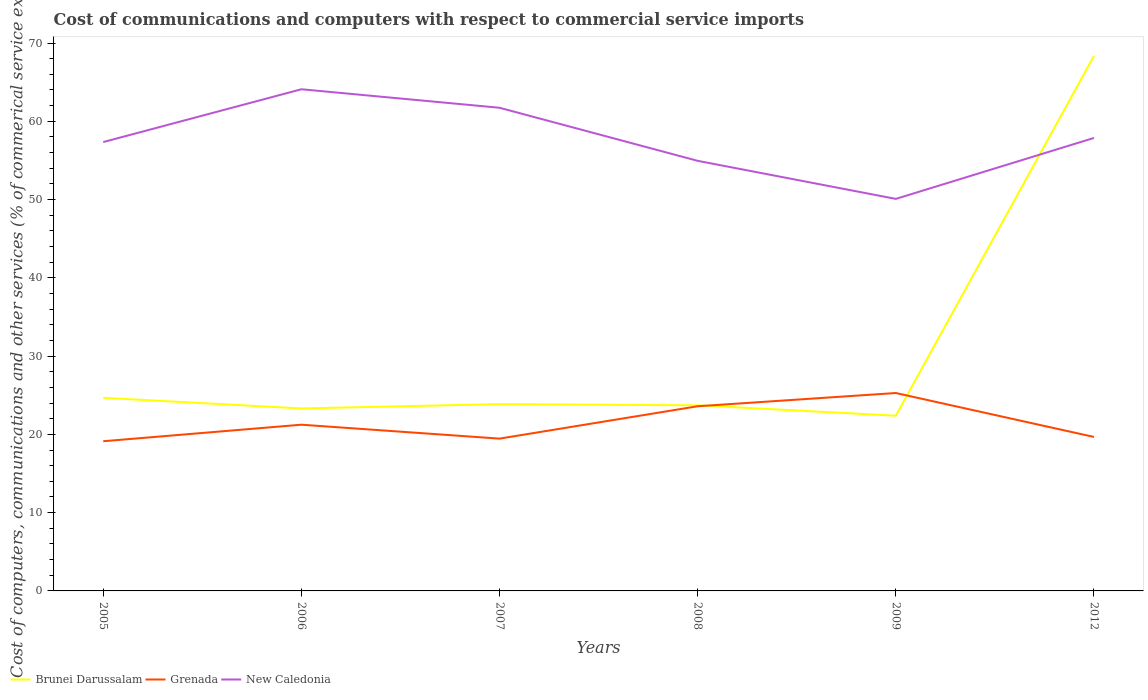Is the number of lines equal to the number of legend labels?
Offer a very short reply. Yes. Across all years, what is the maximum cost of communications and computers in Brunei Darussalam?
Your response must be concise. 22.39. In which year was the cost of communications and computers in New Caledonia maximum?
Provide a succinct answer. 2009. What is the total cost of communications and computers in Grenada in the graph?
Provide a short and direct response. -6.16. What is the difference between the highest and the second highest cost of communications and computers in Brunei Darussalam?
Keep it short and to the point. 45.97. What is the difference between the highest and the lowest cost of communications and computers in Brunei Darussalam?
Ensure brevity in your answer.  1. Is the cost of communications and computers in New Caledonia strictly greater than the cost of communications and computers in Grenada over the years?
Provide a succinct answer. No. How many lines are there?
Offer a very short reply. 3. How many years are there in the graph?
Make the answer very short. 6. How many legend labels are there?
Your answer should be compact. 3. How are the legend labels stacked?
Ensure brevity in your answer.  Horizontal. What is the title of the graph?
Give a very brief answer. Cost of communications and computers with respect to commercial service imports. Does "Caribbean small states" appear as one of the legend labels in the graph?
Offer a terse response. No. What is the label or title of the Y-axis?
Offer a very short reply. Cost of computers, communications and other services (% of commerical service exports). What is the Cost of computers, communications and other services (% of commerical service exports) of Brunei Darussalam in 2005?
Your answer should be very brief. 24.67. What is the Cost of computers, communications and other services (% of commerical service exports) in Grenada in 2005?
Your response must be concise. 19.12. What is the Cost of computers, communications and other services (% of commerical service exports) in New Caledonia in 2005?
Provide a succinct answer. 57.35. What is the Cost of computers, communications and other services (% of commerical service exports) in Brunei Darussalam in 2006?
Ensure brevity in your answer.  23.31. What is the Cost of computers, communications and other services (% of commerical service exports) in Grenada in 2006?
Keep it short and to the point. 21.24. What is the Cost of computers, communications and other services (% of commerical service exports) of New Caledonia in 2006?
Offer a very short reply. 64.09. What is the Cost of computers, communications and other services (% of commerical service exports) of Brunei Darussalam in 2007?
Offer a very short reply. 23.87. What is the Cost of computers, communications and other services (% of commerical service exports) in Grenada in 2007?
Give a very brief answer. 19.46. What is the Cost of computers, communications and other services (% of commerical service exports) in New Caledonia in 2007?
Make the answer very short. 61.73. What is the Cost of computers, communications and other services (% of commerical service exports) of Brunei Darussalam in 2008?
Your answer should be compact. 23.72. What is the Cost of computers, communications and other services (% of commerical service exports) of Grenada in 2008?
Ensure brevity in your answer.  23.59. What is the Cost of computers, communications and other services (% of commerical service exports) of New Caledonia in 2008?
Offer a very short reply. 54.95. What is the Cost of computers, communications and other services (% of commerical service exports) in Brunei Darussalam in 2009?
Make the answer very short. 22.39. What is the Cost of computers, communications and other services (% of commerical service exports) in Grenada in 2009?
Provide a short and direct response. 25.28. What is the Cost of computers, communications and other services (% of commerical service exports) in New Caledonia in 2009?
Your response must be concise. 50.09. What is the Cost of computers, communications and other services (% of commerical service exports) in Brunei Darussalam in 2012?
Offer a very short reply. 68.36. What is the Cost of computers, communications and other services (% of commerical service exports) of Grenada in 2012?
Your answer should be very brief. 19.67. What is the Cost of computers, communications and other services (% of commerical service exports) in New Caledonia in 2012?
Your response must be concise. 57.87. Across all years, what is the maximum Cost of computers, communications and other services (% of commerical service exports) in Brunei Darussalam?
Provide a short and direct response. 68.36. Across all years, what is the maximum Cost of computers, communications and other services (% of commerical service exports) of Grenada?
Offer a terse response. 25.28. Across all years, what is the maximum Cost of computers, communications and other services (% of commerical service exports) of New Caledonia?
Offer a very short reply. 64.09. Across all years, what is the minimum Cost of computers, communications and other services (% of commerical service exports) of Brunei Darussalam?
Provide a short and direct response. 22.39. Across all years, what is the minimum Cost of computers, communications and other services (% of commerical service exports) of Grenada?
Make the answer very short. 19.12. Across all years, what is the minimum Cost of computers, communications and other services (% of commerical service exports) of New Caledonia?
Ensure brevity in your answer.  50.09. What is the total Cost of computers, communications and other services (% of commerical service exports) in Brunei Darussalam in the graph?
Provide a succinct answer. 186.32. What is the total Cost of computers, communications and other services (% of commerical service exports) in Grenada in the graph?
Provide a succinct answer. 128.37. What is the total Cost of computers, communications and other services (% of commerical service exports) of New Caledonia in the graph?
Provide a short and direct response. 346.08. What is the difference between the Cost of computers, communications and other services (% of commerical service exports) of Brunei Darussalam in 2005 and that in 2006?
Ensure brevity in your answer.  1.36. What is the difference between the Cost of computers, communications and other services (% of commerical service exports) of Grenada in 2005 and that in 2006?
Your answer should be compact. -2.11. What is the difference between the Cost of computers, communications and other services (% of commerical service exports) in New Caledonia in 2005 and that in 2006?
Ensure brevity in your answer.  -6.75. What is the difference between the Cost of computers, communications and other services (% of commerical service exports) of Brunei Darussalam in 2005 and that in 2007?
Your answer should be very brief. 0.81. What is the difference between the Cost of computers, communications and other services (% of commerical service exports) of Grenada in 2005 and that in 2007?
Keep it short and to the point. -0.33. What is the difference between the Cost of computers, communications and other services (% of commerical service exports) in New Caledonia in 2005 and that in 2007?
Your response must be concise. -4.38. What is the difference between the Cost of computers, communications and other services (% of commerical service exports) of Brunei Darussalam in 2005 and that in 2008?
Your response must be concise. 0.96. What is the difference between the Cost of computers, communications and other services (% of commerical service exports) in Grenada in 2005 and that in 2008?
Your answer should be very brief. -4.47. What is the difference between the Cost of computers, communications and other services (% of commerical service exports) of New Caledonia in 2005 and that in 2008?
Make the answer very short. 2.4. What is the difference between the Cost of computers, communications and other services (% of commerical service exports) in Brunei Darussalam in 2005 and that in 2009?
Offer a very short reply. 2.28. What is the difference between the Cost of computers, communications and other services (% of commerical service exports) in Grenada in 2005 and that in 2009?
Make the answer very short. -6.16. What is the difference between the Cost of computers, communications and other services (% of commerical service exports) of New Caledonia in 2005 and that in 2009?
Offer a terse response. 7.26. What is the difference between the Cost of computers, communications and other services (% of commerical service exports) in Brunei Darussalam in 2005 and that in 2012?
Provide a short and direct response. -43.69. What is the difference between the Cost of computers, communications and other services (% of commerical service exports) in Grenada in 2005 and that in 2012?
Provide a succinct answer. -0.55. What is the difference between the Cost of computers, communications and other services (% of commerical service exports) in New Caledonia in 2005 and that in 2012?
Provide a succinct answer. -0.53. What is the difference between the Cost of computers, communications and other services (% of commerical service exports) in Brunei Darussalam in 2006 and that in 2007?
Your answer should be very brief. -0.55. What is the difference between the Cost of computers, communications and other services (% of commerical service exports) of Grenada in 2006 and that in 2007?
Provide a succinct answer. 1.78. What is the difference between the Cost of computers, communications and other services (% of commerical service exports) of New Caledonia in 2006 and that in 2007?
Give a very brief answer. 2.36. What is the difference between the Cost of computers, communications and other services (% of commerical service exports) in Brunei Darussalam in 2006 and that in 2008?
Your answer should be very brief. -0.4. What is the difference between the Cost of computers, communications and other services (% of commerical service exports) in Grenada in 2006 and that in 2008?
Your answer should be very brief. -2.36. What is the difference between the Cost of computers, communications and other services (% of commerical service exports) in New Caledonia in 2006 and that in 2008?
Provide a succinct answer. 9.14. What is the difference between the Cost of computers, communications and other services (% of commerical service exports) of Brunei Darussalam in 2006 and that in 2009?
Ensure brevity in your answer.  0.92. What is the difference between the Cost of computers, communications and other services (% of commerical service exports) in Grenada in 2006 and that in 2009?
Offer a very short reply. -4.05. What is the difference between the Cost of computers, communications and other services (% of commerical service exports) of New Caledonia in 2006 and that in 2009?
Provide a succinct answer. 14.01. What is the difference between the Cost of computers, communications and other services (% of commerical service exports) in Brunei Darussalam in 2006 and that in 2012?
Your answer should be very brief. -45.05. What is the difference between the Cost of computers, communications and other services (% of commerical service exports) in Grenada in 2006 and that in 2012?
Offer a terse response. 1.57. What is the difference between the Cost of computers, communications and other services (% of commerical service exports) of New Caledonia in 2006 and that in 2012?
Your answer should be compact. 6.22. What is the difference between the Cost of computers, communications and other services (% of commerical service exports) in Brunei Darussalam in 2007 and that in 2008?
Provide a short and direct response. 0.15. What is the difference between the Cost of computers, communications and other services (% of commerical service exports) of Grenada in 2007 and that in 2008?
Make the answer very short. -4.14. What is the difference between the Cost of computers, communications and other services (% of commerical service exports) in New Caledonia in 2007 and that in 2008?
Your answer should be very brief. 6.78. What is the difference between the Cost of computers, communications and other services (% of commerical service exports) of Brunei Darussalam in 2007 and that in 2009?
Offer a terse response. 1.48. What is the difference between the Cost of computers, communications and other services (% of commerical service exports) in Grenada in 2007 and that in 2009?
Offer a very short reply. -5.83. What is the difference between the Cost of computers, communications and other services (% of commerical service exports) of New Caledonia in 2007 and that in 2009?
Make the answer very short. 11.64. What is the difference between the Cost of computers, communications and other services (% of commerical service exports) of Brunei Darussalam in 2007 and that in 2012?
Keep it short and to the point. -44.5. What is the difference between the Cost of computers, communications and other services (% of commerical service exports) in Grenada in 2007 and that in 2012?
Provide a short and direct response. -0.21. What is the difference between the Cost of computers, communications and other services (% of commerical service exports) of New Caledonia in 2007 and that in 2012?
Provide a short and direct response. 3.85. What is the difference between the Cost of computers, communications and other services (% of commerical service exports) in Brunei Darussalam in 2008 and that in 2009?
Give a very brief answer. 1.33. What is the difference between the Cost of computers, communications and other services (% of commerical service exports) in Grenada in 2008 and that in 2009?
Keep it short and to the point. -1.69. What is the difference between the Cost of computers, communications and other services (% of commerical service exports) in New Caledonia in 2008 and that in 2009?
Ensure brevity in your answer.  4.86. What is the difference between the Cost of computers, communications and other services (% of commerical service exports) in Brunei Darussalam in 2008 and that in 2012?
Your answer should be very brief. -44.65. What is the difference between the Cost of computers, communications and other services (% of commerical service exports) of Grenada in 2008 and that in 2012?
Your answer should be compact. 3.92. What is the difference between the Cost of computers, communications and other services (% of commerical service exports) of New Caledonia in 2008 and that in 2012?
Make the answer very short. -2.93. What is the difference between the Cost of computers, communications and other services (% of commerical service exports) of Brunei Darussalam in 2009 and that in 2012?
Offer a terse response. -45.97. What is the difference between the Cost of computers, communications and other services (% of commerical service exports) in Grenada in 2009 and that in 2012?
Your response must be concise. 5.61. What is the difference between the Cost of computers, communications and other services (% of commerical service exports) of New Caledonia in 2009 and that in 2012?
Offer a terse response. -7.79. What is the difference between the Cost of computers, communications and other services (% of commerical service exports) of Brunei Darussalam in 2005 and the Cost of computers, communications and other services (% of commerical service exports) of Grenada in 2006?
Keep it short and to the point. 3.44. What is the difference between the Cost of computers, communications and other services (% of commerical service exports) in Brunei Darussalam in 2005 and the Cost of computers, communications and other services (% of commerical service exports) in New Caledonia in 2006?
Your response must be concise. -39.42. What is the difference between the Cost of computers, communications and other services (% of commerical service exports) in Grenada in 2005 and the Cost of computers, communications and other services (% of commerical service exports) in New Caledonia in 2006?
Your response must be concise. -44.97. What is the difference between the Cost of computers, communications and other services (% of commerical service exports) of Brunei Darussalam in 2005 and the Cost of computers, communications and other services (% of commerical service exports) of Grenada in 2007?
Give a very brief answer. 5.21. What is the difference between the Cost of computers, communications and other services (% of commerical service exports) in Brunei Darussalam in 2005 and the Cost of computers, communications and other services (% of commerical service exports) in New Caledonia in 2007?
Make the answer very short. -37.06. What is the difference between the Cost of computers, communications and other services (% of commerical service exports) in Grenada in 2005 and the Cost of computers, communications and other services (% of commerical service exports) in New Caledonia in 2007?
Your answer should be compact. -42.6. What is the difference between the Cost of computers, communications and other services (% of commerical service exports) of Brunei Darussalam in 2005 and the Cost of computers, communications and other services (% of commerical service exports) of Grenada in 2008?
Make the answer very short. 1.08. What is the difference between the Cost of computers, communications and other services (% of commerical service exports) of Brunei Darussalam in 2005 and the Cost of computers, communications and other services (% of commerical service exports) of New Caledonia in 2008?
Your answer should be very brief. -30.28. What is the difference between the Cost of computers, communications and other services (% of commerical service exports) of Grenada in 2005 and the Cost of computers, communications and other services (% of commerical service exports) of New Caledonia in 2008?
Make the answer very short. -35.82. What is the difference between the Cost of computers, communications and other services (% of commerical service exports) of Brunei Darussalam in 2005 and the Cost of computers, communications and other services (% of commerical service exports) of Grenada in 2009?
Offer a very short reply. -0.61. What is the difference between the Cost of computers, communications and other services (% of commerical service exports) in Brunei Darussalam in 2005 and the Cost of computers, communications and other services (% of commerical service exports) in New Caledonia in 2009?
Ensure brevity in your answer.  -25.41. What is the difference between the Cost of computers, communications and other services (% of commerical service exports) of Grenada in 2005 and the Cost of computers, communications and other services (% of commerical service exports) of New Caledonia in 2009?
Keep it short and to the point. -30.96. What is the difference between the Cost of computers, communications and other services (% of commerical service exports) in Brunei Darussalam in 2005 and the Cost of computers, communications and other services (% of commerical service exports) in Grenada in 2012?
Offer a very short reply. 5. What is the difference between the Cost of computers, communications and other services (% of commerical service exports) in Brunei Darussalam in 2005 and the Cost of computers, communications and other services (% of commerical service exports) in New Caledonia in 2012?
Your answer should be very brief. -33.2. What is the difference between the Cost of computers, communications and other services (% of commerical service exports) of Grenada in 2005 and the Cost of computers, communications and other services (% of commerical service exports) of New Caledonia in 2012?
Provide a short and direct response. -38.75. What is the difference between the Cost of computers, communications and other services (% of commerical service exports) of Brunei Darussalam in 2006 and the Cost of computers, communications and other services (% of commerical service exports) of Grenada in 2007?
Your answer should be compact. 3.85. What is the difference between the Cost of computers, communications and other services (% of commerical service exports) in Brunei Darussalam in 2006 and the Cost of computers, communications and other services (% of commerical service exports) in New Caledonia in 2007?
Provide a short and direct response. -38.42. What is the difference between the Cost of computers, communications and other services (% of commerical service exports) in Grenada in 2006 and the Cost of computers, communications and other services (% of commerical service exports) in New Caledonia in 2007?
Offer a very short reply. -40.49. What is the difference between the Cost of computers, communications and other services (% of commerical service exports) of Brunei Darussalam in 2006 and the Cost of computers, communications and other services (% of commerical service exports) of Grenada in 2008?
Offer a very short reply. -0.28. What is the difference between the Cost of computers, communications and other services (% of commerical service exports) of Brunei Darussalam in 2006 and the Cost of computers, communications and other services (% of commerical service exports) of New Caledonia in 2008?
Keep it short and to the point. -31.64. What is the difference between the Cost of computers, communications and other services (% of commerical service exports) in Grenada in 2006 and the Cost of computers, communications and other services (% of commerical service exports) in New Caledonia in 2008?
Make the answer very short. -33.71. What is the difference between the Cost of computers, communications and other services (% of commerical service exports) in Brunei Darussalam in 2006 and the Cost of computers, communications and other services (% of commerical service exports) in Grenada in 2009?
Your answer should be compact. -1.97. What is the difference between the Cost of computers, communications and other services (% of commerical service exports) in Brunei Darussalam in 2006 and the Cost of computers, communications and other services (% of commerical service exports) in New Caledonia in 2009?
Keep it short and to the point. -26.77. What is the difference between the Cost of computers, communications and other services (% of commerical service exports) in Grenada in 2006 and the Cost of computers, communications and other services (% of commerical service exports) in New Caledonia in 2009?
Provide a succinct answer. -28.85. What is the difference between the Cost of computers, communications and other services (% of commerical service exports) of Brunei Darussalam in 2006 and the Cost of computers, communications and other services (% of commerical service exports) of Grenada in 2012?
Provide a short and direct response. 3.64. What is the difference between the Cost of computers, communications and other services (% of commerical service exports) in Brunei Darussalam in 2006 and the Cost of computers, communications and other services (% of commerical service exports) in New Caledonia in 2012?
Your answer should be very brief. -34.56. What is the difference between the Cost of computers, communications and other services (% of commerical service exports) of Grenada in 2006 and the Cost of computers, communications and other services (% of commerical service exports) of New Caledonia in 2012?
Offer a terse response. -36.64. What is the difference between the Cost of computers, communications and other services (% of commerical service exports) in Brunei Darussalam in 2007 and the Cost of computers, communications and other services (% of commerical service exports) in Grenada in 2008?
Provide a short and direct response. 0.27. What is the difference between the Cost of computers, communications and other services (% of commerical service exports) in Brunei Darussalam in 2007 and the Cost of computers, communications and other services (% of commerical service exports) in New Caledonia in 2008?
Keep it short and to the point. -31.08. What is the difference between the Cost of computers, communications and other services (% of commerical service exports) in Grenada in 2007 and the Cost of computers, communications and other services (% of commerical service exports) in New Caledonia in 2008?
Your answer should be compact. -35.49. What is the difference between the Cost of computers, communications and other services (% of commerical service exports) of Brunei Darussalam in 2007 and the Cost of computers, communications and other services (% of commerical service exports) of Grenada in 2009?
Offer a very short reply. -1.42. What is the difference between the Cost of computers, communications and other services (% of commerical service exports) in Brunei Darussalam in 2007 and the Cost of computers, communications and other services (% of commerical service exports) in New Caledonia in 2009?
Your response must be concise. -26.22. What is the difference between the Cost of computers, communications and other services (% of commerical service exports) of Grenada in 2007 and the Cost of computers, communications and other services (% of commerical service exports) of New Caledonia in 2009?
Your answer should be very brief. -30.63. What is the difference between the Cost of computers, communications and other services (% of commerical service exports) in Brunei Darussalam in 2007 and the Cost of computers, communications and other services (% of commerical service exports) in Grenada in 2012?
Your response must be concise. 4.2. What is the difference between the Cost of computers, communications and other services (% of commerical service exports) in Brunei Darussalam in 2007 and the Cost of computers, communications and other services (% of commerical service exports) in New Caledonia in 2012?
Give a very brief answer. -34.01. What is the difference between the Cost of computers, communications and other services (% of commerical service exports) in Grenada in 2007 and the Cost of computers, communications and other services (% of commerical service exports) in New Caledonia in 2012?
Give a very brief answer. -38.42. What is the difference between the Cost of computers, communications and other services (% of commerical service exports) in Brunei Darussalam in 2008 and the Cost of computers, communications and other services (% of commerical service exports) in Grenada in 2009?
Ensure brevity in your answer.  -1.57. What is the difference between the Cost of computers, communications and other services (% of commerical service exports) of Brunei Darussalam in 2008 and the Cost of computers, communications and other services (% of commerical service exports) of New Caledonia in 2009?
Your answer should be very brief. -26.37. What is the difference between the Cost of computers, communications and other services (% of commerical service exports) in Grenada in 2008 and the Cost of computers, communications and other services (% of commerical service exports) in New Caledonia in 2009?
Your answer should be very brief. -26.49. What is the difference between the Cost of computers, communications and other services (% of commerical service exports) of Brunei Darussalam in 2008 and the Cost of computers, communications and other services (% of commerical service exports) of Grenada in 2012?
Provide a succinct answer. 4.05. What is the difference between the Cost of computers, communications and other services (% of commerical service exports) of Brunei Darussalam in 2008 and the Cost of computers, communications and other services (% of commerical service exports) of New Caledonia in 2012?
Your answer should be very brief. -34.16. What is the difference between the Cost of computers, communications and other services (% of commerical service exports) in Grenada in 2008 and the Cost of computers, communications and other services (% of commerical service exports) in New Caledonia in 2012?
Provide a short and direct response. -34.28. What is the difference between the Cost of computers, communications and other services (% of commerical service exports) of Brunei Darussalam in 2009 and the Cost of computers, communications and other services (% of commerical service exports) of Grenada in 2012?
Your answer should be very brief. 2.72. What is the difference between the Cost of computers, communications and other services (% of commerical service exports) of Brunei Darussalam in 2009 and the Cost of computers, communications and other services (% of commerical service exports) of New Caledonia in 2012?
Provide a succinct answer. -35.49. What is the difference between the Cost of computers, communications and other services (% of commerical service exports) in Grenada in 2009 and the Cost of computers, communications and other services (% of commerical service exports) in New Caledonia in 2012?
Your answer should be compact. -32.59. What is the average Cost of computers, communications and other services (% of commerical service exports) in Brunei Darussalam per year?
Ensure brevity in your answer.  31.05. What is the average Cost of computers, communications and other services (% of commerical service exports) in Grenada per year?
Offer a terse response. 21.39. What is the average Cost of computers, communications and other services (% of commerical service exports) of New Caledonia per year?
Your response must be concise. 57.68. In the year 2005, what is the difference between the Cost of computers, communications and other services (% of commerical service exports) in Brunei Darussalam and Cost of computers, communications and other services (% of commerical service exports) in Grenada?
Provide a succinct answer. 5.55. In the year 2005, what is the difference between the Cost of computers, communications and other services (% of commerical service exports) in Brunei Darussalam and Cost of computers, communications and other services (% of commerical service exports) in New Caledonia?
Give a very brief answer. -32.67. In the year 2005, what is the difference between the Cost of computers, communications and other services (% of commerical service exports) of Grenada and Cost of computers, communications and other services (% of commerical service exports) of New Caledonia?
Ensure brevity in your answer.  -38.22. In the year 2006, what is the difference between the Cost of computers, communications and other services (% of commerical service exports) of Brunei Darussalam and Cost of computers, communications and other services (% of commerical service exports) of Grenada?
Your answer should be compact. 2.08. In the year 2006, what is the difference between the Cost of computers, communications and other services (% of commerical service exports) in Brunei Darussalam and Cost of computers, communications and other services (% of commerical service exports) in New Caledonia?
Provide a succinct answer. -40.78. In the year 2006, what is the difference between the Cost of computers, communications and other services (% of commerical service exports) in Grenada and Cost of computers, communications and other services (% of commerical service exports) in New Caledonia?
Make the answer very short. -42.86. In the year 2007, what is the difference between the Cost of computers, communications and other services (% of commerical service exports) in Brunei Darussalam and Cost of computers, communications and other services (% of commerical service exports) in Grenada?
Offer a very short reply. 4.41. In the year 2007, what is the difference between the Cost of computers, communications and other services (% of commerical service exports) in Brunei Darussalam and Cost of computers, communications and other services (% of commerical service exports) in New Caledonia?
Your answer should be very brief. -37.86. In the year 2007, what is the difference between the Cost of computers, communications and other services (% of commerical service exports) in Grenada and Cost of computers, communications and other services (% of commerical service exports) in New Caledonia?
Offer a terse response. -42.27. In the year 2008, what is the difference between the Cost of computers, communications and other services (% of commerical service exports) in Brunei Darussalam and Cost of computers, communications and other services (% of commerical service exports) in Grenada?
Your response must be concise. 0.12. In the year 2008, what is the difference between the Cost of computers, communications and other services (% of commerical service exports) of Brunei Darussalam and Cost of computers, communications and other services (% of commerical service exports) of New Caledonia?
Your answer should be compact. -31.23. In the year 2008, what is the difference between the Cost of computers, communications and other services (% of commerical service exports) in Grenada and Cost of computers, communications and other services (% of commerical service exports) in New Caledonia?
Your answer should be compact. -31.35. In the year 2009, what is the difference between the Cost of computers, communications and other services (% of commerical service exports) of Brunei Darussalam and Cost of computers, communications and other services (% of commerical service exports) of Grenada?
Provide a short and direct response. -2.9. In the year 2009, what is the difference between the Cost of computers, communications and other services (% of commerical service exports) of Brunei Darussalam and Cost of computers, communications and other services (% of commerical service exports) of New Caledonia?
Your answer should be compact. -27.7. In the year 2009, what is the difference between the Cost of computers, communications and other services (% of commerical service exports) in Grenada and Cost of computers, communications and other services (% of commerical service exports) in New Caledonia?
Your answer should be very brief. -24.8. In the year 2012, what is the difference between the Cost of computers, communications and other services (% of commerical service exports) in Brunei Darussalam and Cost of computers, communications and other services (% of commerical service exports) in Grenada?
Your answer should be very brief. 48.69. In the year 2012, what is the difference between the Cost of computers, communications and other services (% of commerical service exports) of Brunei Darussalam and Cost of computers, communications and other services (% of commerical service exports) of New Caledonia?
Your answer should be compact. 10.49. In the year 2012, what is the difference between the Cost of computers, communications and other services (% of commerical service exports) of Grenada and Cost of computers, communications and other services (% of commerical service exports) of New Caledonia?
Ensure brevity in your answer.  -38.2. What is the ratio of the Cost of computers, communications and other services (% of commerical service exports) of Brunei Darussalam in 2005 to that in 2006?
Your answer should be compact. 1.06. What is the ratio of the Cost of computers, communications and other services (% of commerical service exports) of Grenada in 2005 to that in 2006?
Offer a terse response. 0.9. What is the ratio of the Cost of computers, communications and other services (% of commerical service exports) in New Caledonia in 2005 to that in 2006?
Your answer should be very brief. 0.89. What is the ratio of the Cost of computers, communications and other services (% of commerical service exports) in Brunei Darussalam in 2005 to that in 2007?
Offer a terse response. 1.03. What is the ratio of the Cost of computers, communications and other services (% of commerical service exports) of Grenada in 2005 to that in 2007?
Make the answer very short. 0.98. What is the ratio of the Cost of computers, communications and other services (% of commerical service exports) of New Caledonia in 2005 to that in 2007?
Your answer should be compact. 0.93. What is the ratio of the Cost of computers, communications and other services (% of commerical service exports) of Brunei Darussalam in 2005 to that in 2008?
Offer a terse response. 1.04. What is the ratio of the Cost of computers, communications and other services (% of commerical service exports) of Grenada in 2005 to that in 2008?
Make the answer very short. 0.81. What is the ratio of the Cost of computers, communications and other services (% of commerical service exports) of New Caledonia in 2005 to that in 2008?
Give a very brief answer. 1.04. What is the ratio of the Cost of computers, communications and other services (% of commerical service exports) of Brunei Darussalam in 2005 to that in 2009?
Your response must be concise. 1.1. What is the ratio of the Cost of computers, communications and other services (% of commerical service exports) of Grenada in 2005 to that in 2009?
Your response must be concise. 0.76. What is the ratio of the Cost of computers, communications and other services (% of commerical service exports) in New Caledonia in 2005 to that in 2009?
Provide a succinct answer. 1.14. What is the ratio of the Cost of computers, communications and other services (% of commerical service exports) of Brunei Darussalam in 2005 to that in 2012?
Offer a terse response. 0.36. What is the ratio of the Cost of computers, communications and other services (% of commerical service exports) of Grenada in 2005 to that in 2012?
Your answer should be very brief. 0.97. What is the ratio of the Cost of computers, communications and other services (% of commerical service exports) in New Caledonia in 2005 to that in 2012?
Offer a very short reply. 0.99. What is the ratio of the Cost of computers, communications and other services (% of commerical service exports) in Brunei Darussalam in 2006 to that in 2007?
Provide a succinct answer. 0.98. What is the ratio of the Cost of computers, communications and other services (% of commerical service exports) of Grenada in 2006 to that in 2007?
Your answer should be very brief. 1.09. What is the ratio of the Cost of computers, communications and other services (% of commerical service exports) of New Caledonia in 2006 to that in 2007?
Offer a terse response. 1.04. What is the ratio of the Cost of computers, communications and other services (% of commerical service exports) of Grenada in 2006 to that in 2008?
Your answer should be very brief. 0.9. What is the ratio of the Cost of computers, communications and other services (% of commerical service exports) of New Caledonia in 2006 to that in 2008?
Provide a succinct answer. 1.17. What is the ratio of the Cost of computers, communications and other services (% of commerical service exports) of Brunei Darussalam in 2006 to that in 2009?
Make the answer very short. 1.04. What is the ratio of the Cost of computers, communications and other services (% of commerical service exports) of Grenada in 2006 to that in 2009?
Keep it short and to the point. 0.84. What is the ratio of the Cost of computers, communications and other services (% of commerical service exports) of New Caledonia in 2006 to that in 2009?
Keep it short and to the point. 1.28. What is the ratio of the Cost of computers, communications and other services (% of commerical service exports) in Brunei Darussalam in 2006 to that in 2012?
Ensure brevity in your answer.  0.34. What is the ratio of the Cost of computers, communications and other services (% of commerical service exports) in Grenada in 2006 to that in 2012?
Make the answer very short. 1.08. What is the ratio of the Cost of computers, communications and other services (% of commerical service exports) in New Caledonia in 2006 to that in 2012?
Provide a succinct answer. 1.11. What is the ratio of the Cost of computers, communications and other services (% of commerical service exports) of Brunei Darussalam in 2007 to that in 2008?
Your response must be concise. 1.01. What is the ratio of the Cost of computers, communications and other services (% of commerical service exports) of Grenada in 2007 to that in 2008?
Offer a terse response. 0.82. What is the ratio of the Cost of computers, communications and other services (% of commerical service exports) in New Caledonia in 2007 to that in 2008?
Provide a succinct answer. 1.12. What is the ratio of the Cost of computers, communications and other services (% of commerical service exports) of Brunei Darussalam in 2007 to that in 2009?
Give a very brief answer. 1.07. What is the ratio of the Cost of computers, communications and other services (% of commerical service exports) in Grenada in 2007 to that in 2009?
Offer a very short reply. 0.77. What is the ratio of the Cost of computers, communications and other services (% of commerical service exports) of New Caledonia in 2007 to that in 2009?
Provide a succinct answer. 1.23. What is the ratio of the Cost of computers, communications and other services (% of commerical service exports) of Brunei Darussalam in 2007 to that in 2012?
Your answer should be very brief. 0.35. What is the ratio of the Cost of computers, communications and other services (% of commerical service exports) in Grenada in 2007 to that in 2012?
Provide a succinct answer. 0.99. What is the ratio of the Cost of computers, communications and other services (% of commerical service exports) of New Caledonia in 2007 to that in 2012?
Your response must be concise. 1.07. What is the ratio of the Cost of computers, communications and other services (% of commerical service exports) of Brunei Darussalam in 2008 to that in 2009?
Give a very brief answer. 1.06. What is the ratio of the Cost of computers, communications and other services (% of commerical service exports) in Grenada in 2008 to that in 2009?
Provide a short and direct response. 0.93. What is the ratio of the Cost of computers, communications and other services (% of commerical service exports) in New Caledonia in 2008 to that in 2009?
Provide a succinct answer. 1.1. What is the ratio of the Cost of computers, communications and other services (% of commerical service exports) in Brunei Darussalam in 2008 to that in 2012?
Offer a terse response. 0.35. What is the ratio of the Cost of computers, communications and other services (% of commerical service exports) in Grenada in 2008 to that in 2012?
Offer a very short reply. 1.2. What is the ratio of the Cost of computers, communications and other services (% of commerical service exports) in New Caledonia in 2008 to that in 2012?
Keep it short and to the point. 0.95. What is the ratio of the Cost of computers, communications and other services (% of commerical service exports) of Brunei Darussalam in 2009 to that in 2012?
Your response must be concise. 0.33. What is the ratio of the Cost of computers, communications and other services (% of commerical service exports) of Grenada in 2009 to that in 2012?
Ensure brevity in your answer.  1.29. What is the ratio of the Cost of computers, communications and other services (% of commerical service exports) of New Caledonia in 2009 to that in 2012?
Make the answer very short. 0.87. What is the difference between the highest and the second highest Cost of computers, communications and other services (% of commerical service exports) in Brunei Darussalam?
Offer a terse response. 43.69. What is the difference between the highest and the second highest Cost of computers, communications and other services (% of commerical service exports) of Grenada?
Offer a very short reply. 1.69. What is the difference between the highest and the second highest Cost of computers, communications and other services (% of commerical service exports) of New Caledonia?
Keep it short and to the point. 2.36. What is the difference between the highest and the lowest Cost of computers, communications and other services (% of commerical service exports) in Brunei Darussalam?
Your answer should be very brief. 45.97. What is the difference between the highest and the lowest Cost of computers, communications and other services (% of commerical service exports) in Grenada?
Give a very brief answer. 6.16. What is the difference between the highest and the lowest Cost of computers, communications and other services (% of commerical service exports) of New Caledonia?
Provide a short and direct response. 14.01. 